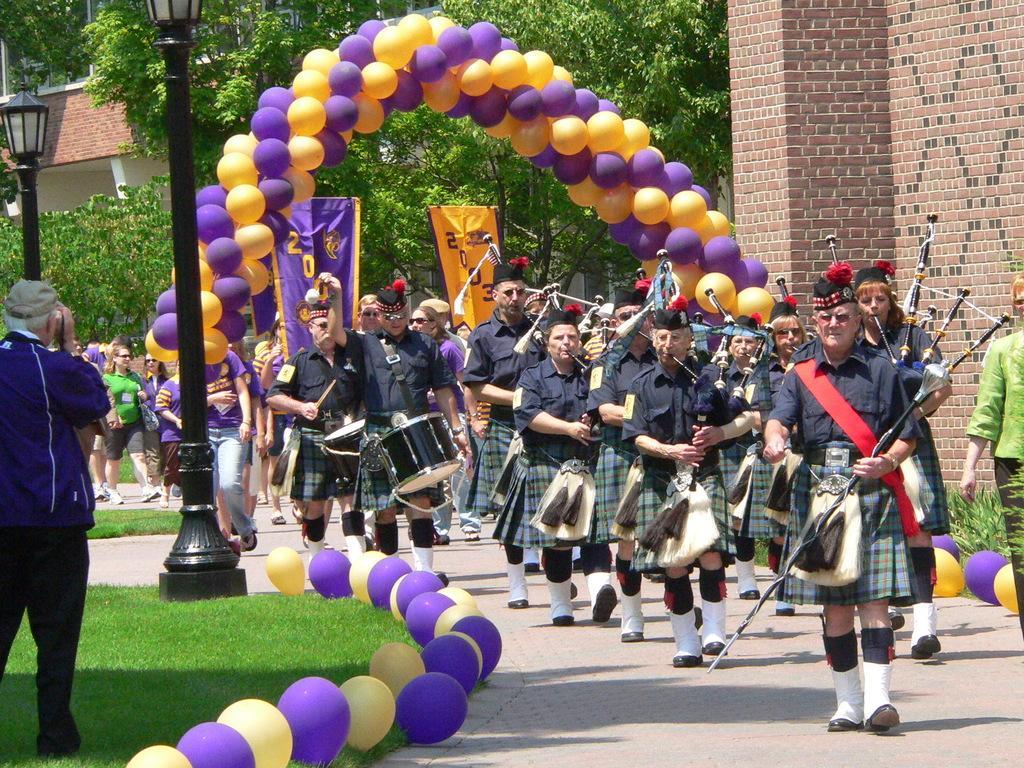How would you summarize this image in a sentence or two? This picture describes about group of people, few people are playing musical instruments and they are walking, and we can see few balloons, poles, lights and trees. 